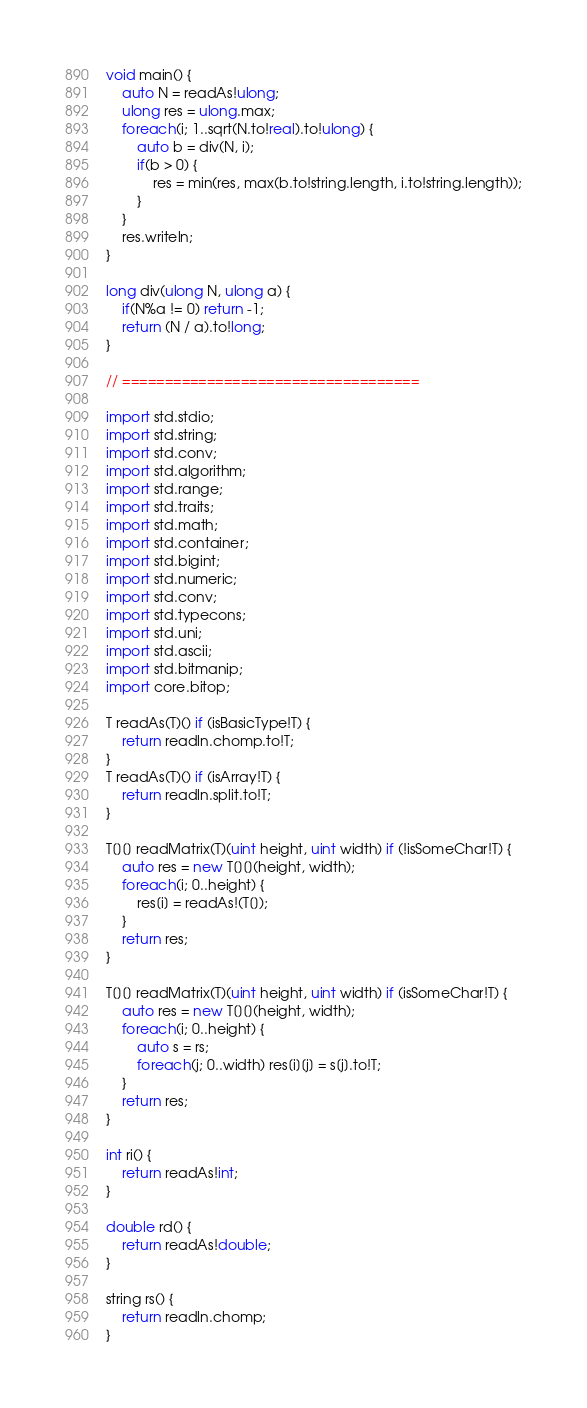<code> <loc_0><loc_0><loc_500><loc_500><_D_>void main() {
	auto N = readAs!ulong;
	ulong res = ulong.max;
	foreach(i; 1..sqrt(N.to!real).to!ulong) {
		auto b = div(N, i);
		if(b > 0) {
			res = min(res, max(b.to!string.length, i.to!string.length));
		}
	}
	res.writeln;
}

long div(ulong N, ulong a) {
	if(N%a != 0) return -1;
	return (N / a).to!long;
}

// ===================================

import std.stdio;
import std.string;
import std.conv;
import std.algorithm;
import std.range;
import std.traits;
import std.math;
import std.container;
import std.bigint;
import std.numeric;
import std.conv;
import std.typecons;
import std.uni;
import std.ascii;
import std.bitmanip;
import core.bitop;

T readAs(T)() if (isBasicType!T) {
	return readln.chomp.to!T;
}
T readAs(T)() if (isArray!T) {
	return readln.split.to!T;
}

T[][] readMatrix(T)(uint height, uint width) if (!isSomeChar!T) {
	auto res = new T[][](height, width);
	foreach(i; 0..height) {
		res[i] = readAs!(T[]);
	}
	return res;
}

T[][] readMatrix(T)(uint height, uint width) if (isSomeChar!T) {
	auto res = new T[][](height, width);
	foreach(i; 0..height) {
		auto s = rs;
		foreach(j; 0..width) res[i][j] = s[j].to!T;
	}
	return res;
}

int ri() {
	return readAs!int;
}

double rd() {
	return readAs!double;
}

string rs() {
	return readln.chomp;
}</code> 